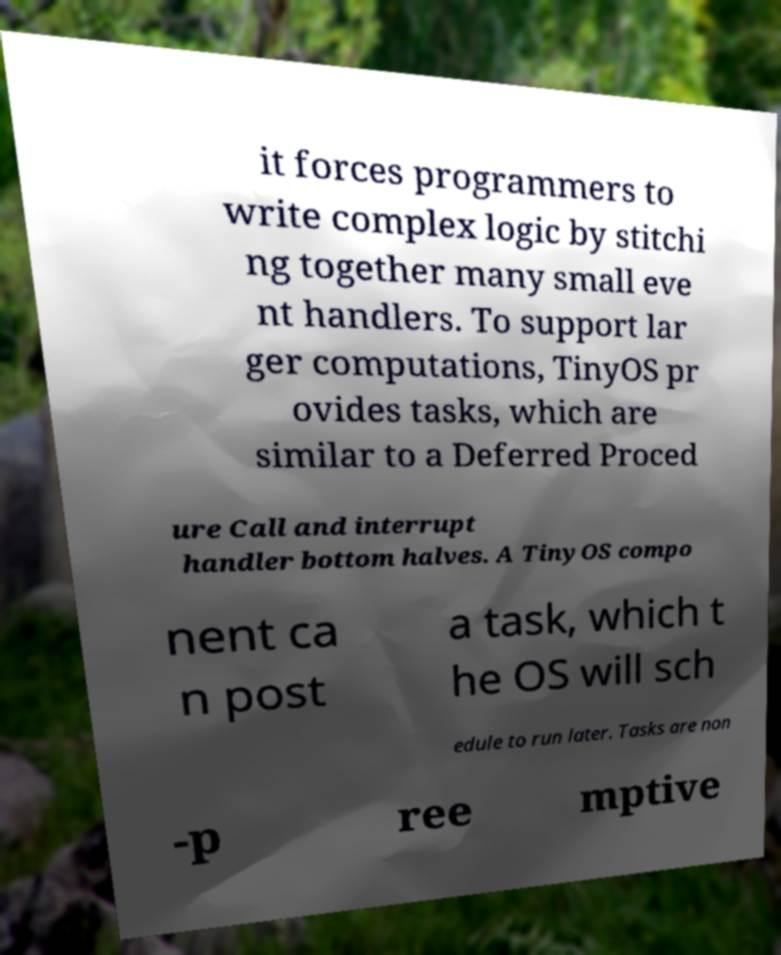Please read and relay the text visible in this image. What does it say? it forces programmers to write complex logic by stitchi ng together many small eve nt handlers. To support lar ger computations, TinyOS pr ovides tasks, which are similar to a Deferred Proced ure Call and interrupt handler bottom halves. A TinyOS compo nent ca n post a task, which t he OS will sch edule to run later. Tasks are non -p ree mptive 